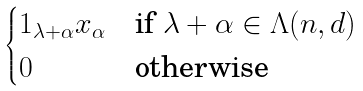<formula> <loc_0><loc_0><loc_500><loc_500>\begin{cases} 1 _ { \lambda + \alpha } x _ { \alpha } & \text {if $\lambda+\alpha \in \Lambda(n,d)$} \\ 0 & \text {otherwise} \end{cases}</formula> 